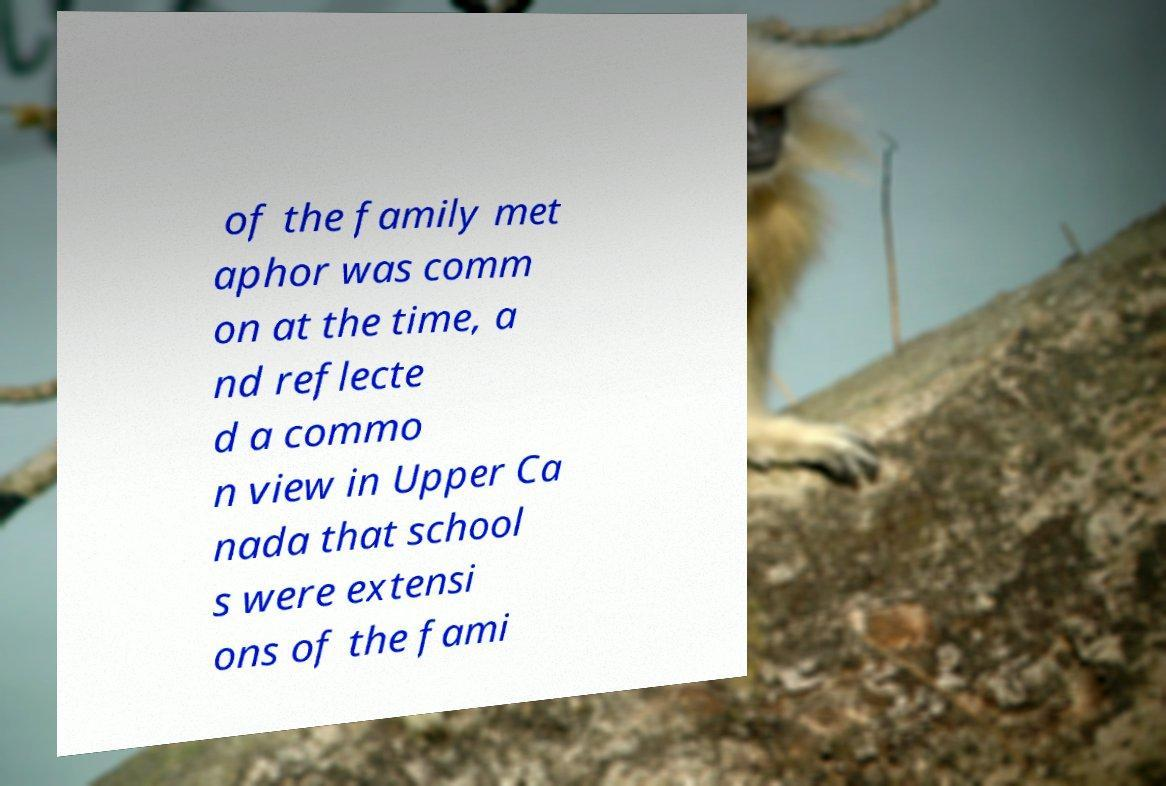Can you read and provide the text displayed in the image?This photo seems to have some interesting text. Can you extract and type it out for me? of the family met aphor was comm on at the time, a nd reflecte d a commo n view in Upper Ca nada that school s were extensi ons of the fami 